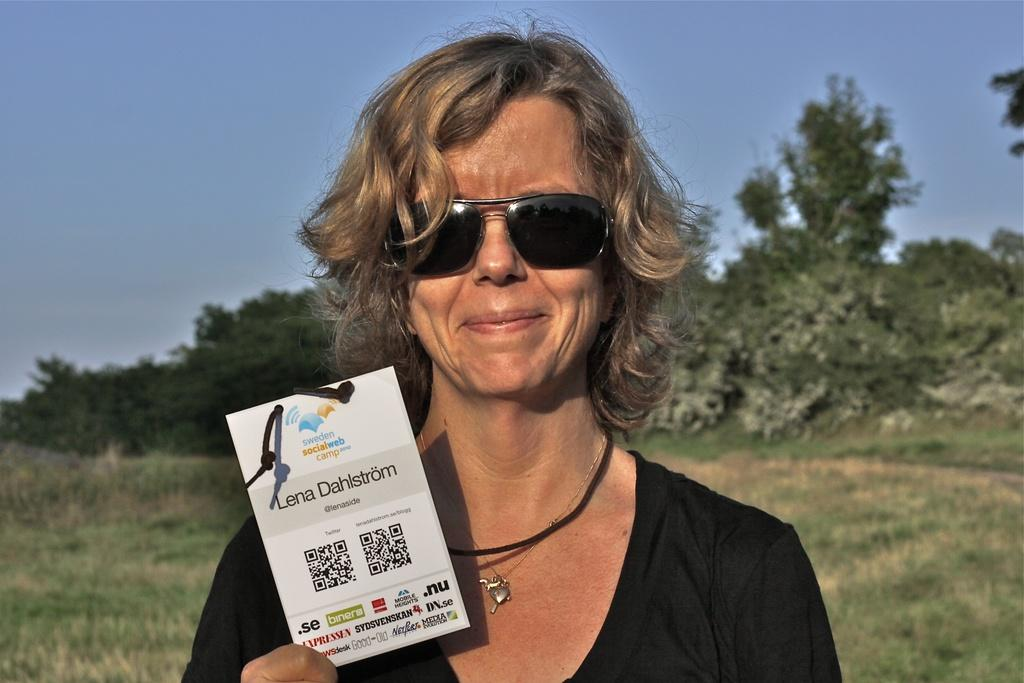What is the woman in the image doing? The woman is standing in the image and holding a card with text. What can be seen in the background of the image? There are trees and grass on the ground in the background, and the sky is visible at the top of the image. What type of scientific experiment is being conducted in the image? There is no scientific experiment present in the image; it features a woman holding a card with text in front of a natural background. 